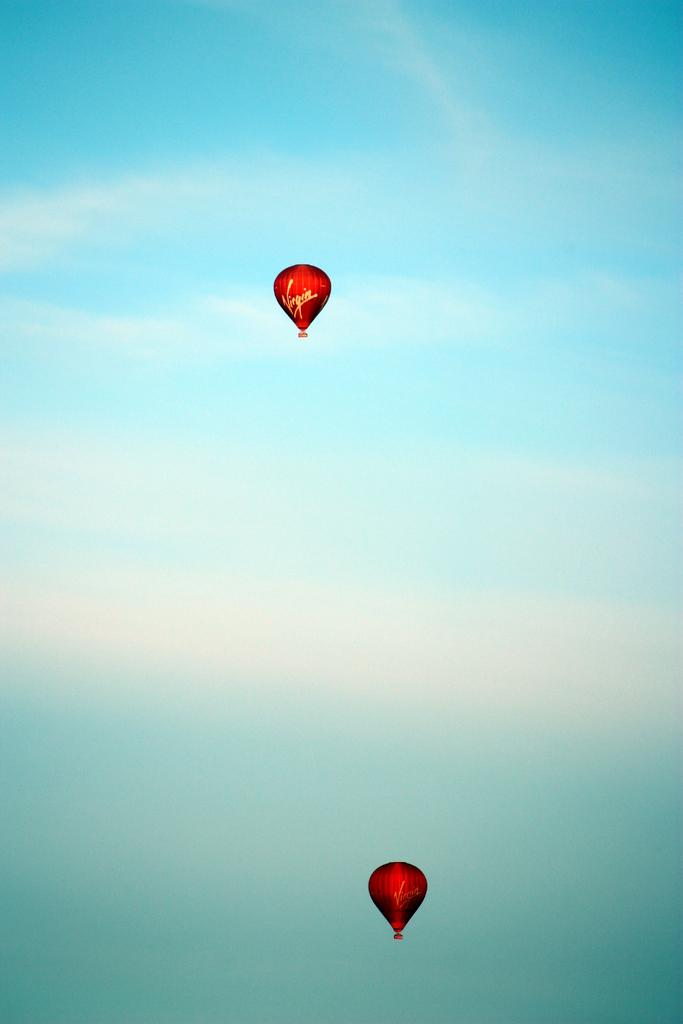What objects are present in the image that are used for descending from a height? There are parachutes in the image. What color are the parachutes in the image? The parachutes are red in color. What is visible in the background of the image? The sky is visible in the image. What is the color of the sky in the image? The sky is blue in color. Where is the meeting taking place in the image? There is no meeting present in the image; it only features parachutes and a blue sky. Can you see any cattle in the image? There are no cattle present in the image. 